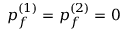<formula> <loc_0><loc_0><loc_500><loc_500>p _ { f } ^ { ( 1 ) } = p _ { f } ^ { ( 2 ) } = 0</formula> 